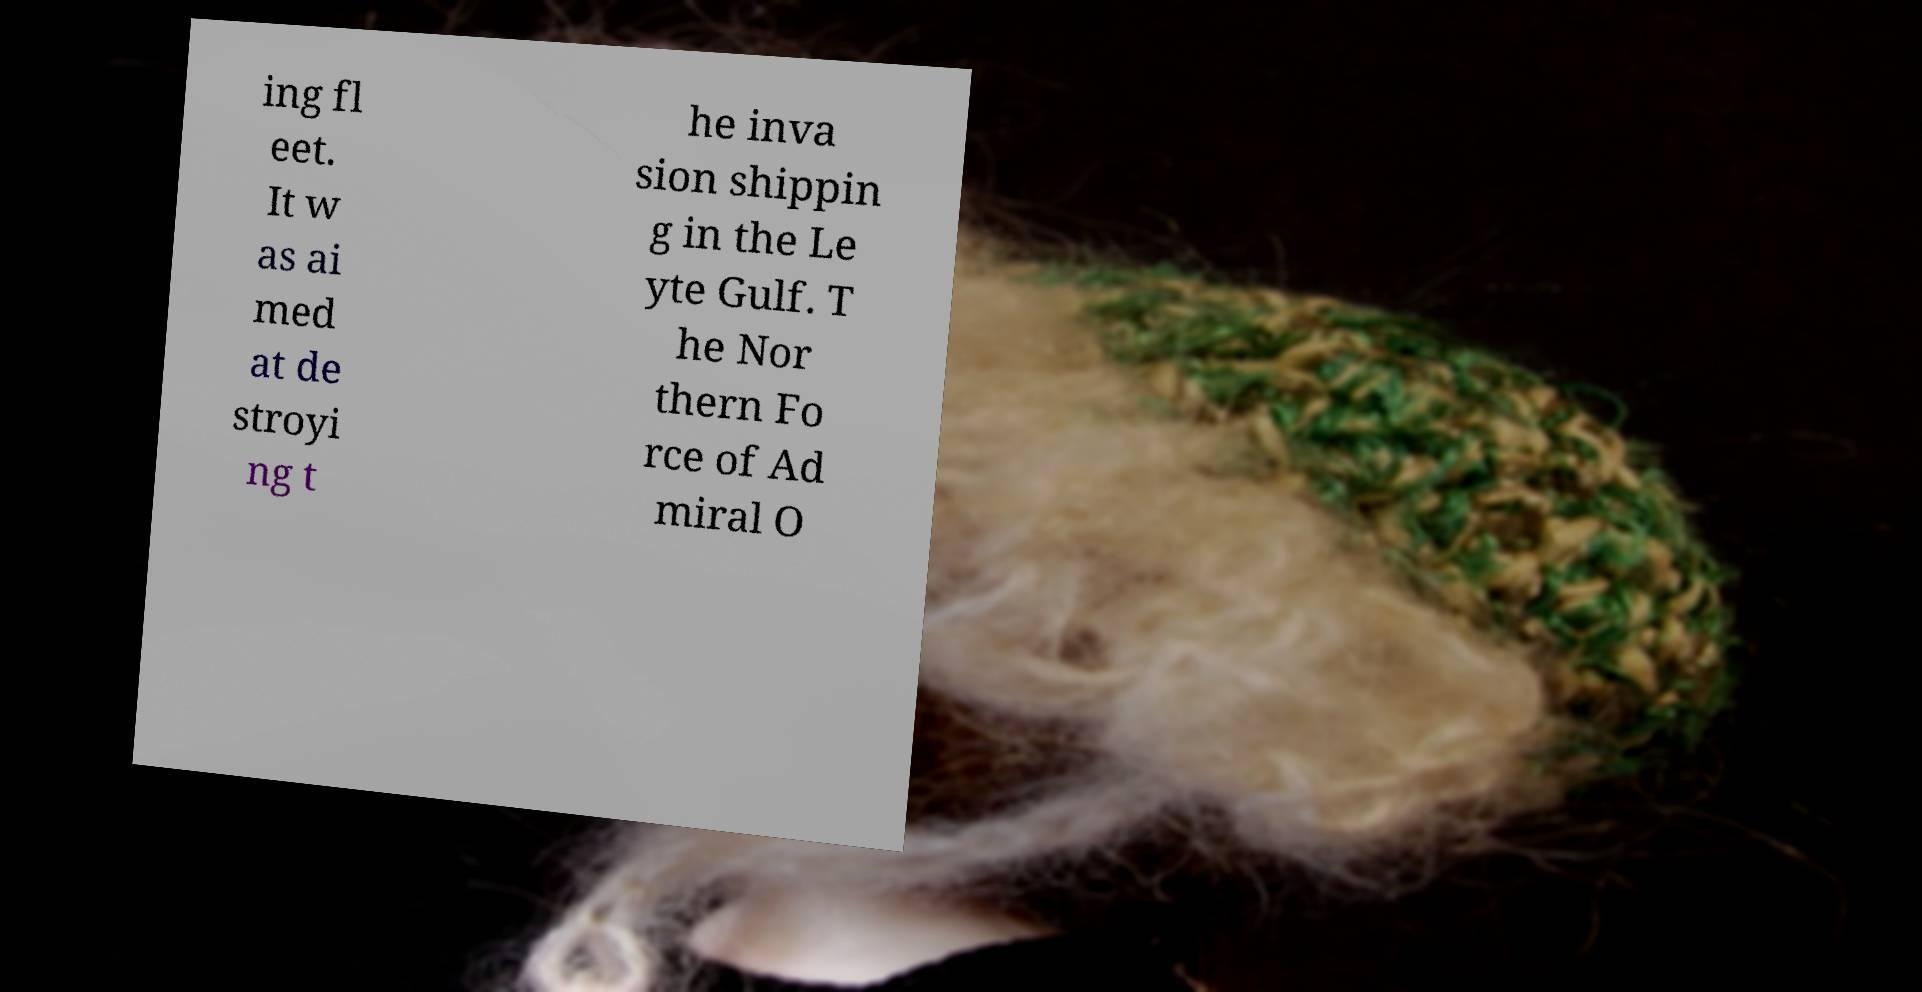Can you accurately transcribe the text from the provided image for me? ing fl eet. It w as ai med at de stroyi ng t he inva sion shippin g in the Le yte Gulf. T he Nor thern Fo rce of Ad miral O 